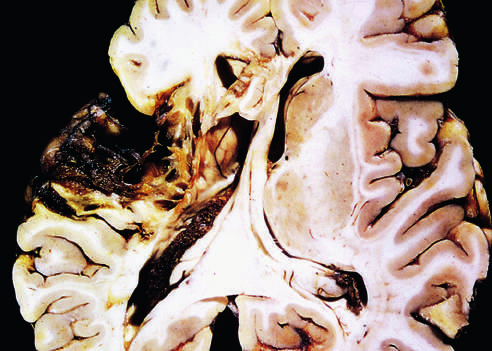does axial tomography show destruction of cortex and surrounding gliosis?
Answer the question using a single word or phrase. No 